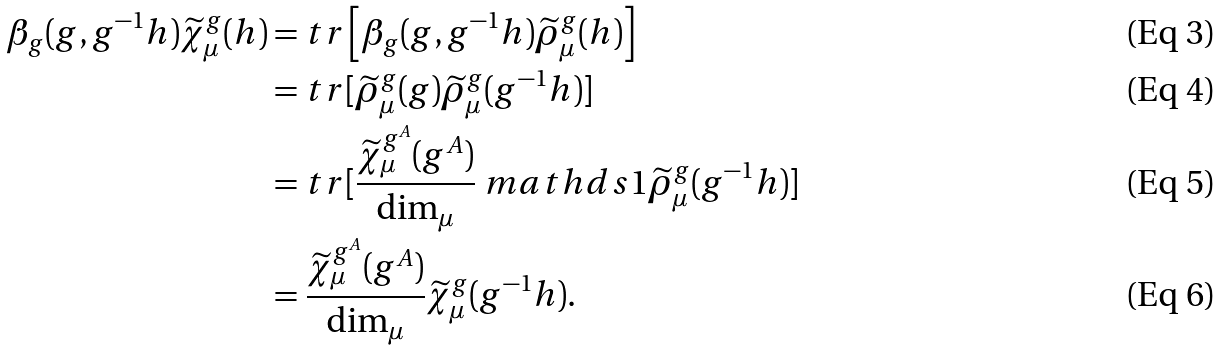<formula> <loc_0><loc_0><loc_500><loc_500>\beta _ { g } ( g , g ^ { - 1 } h ) \widetilde { \chi } ^ { g } _ { \mu } ( h ) & = t r \left [ \beta _ { g } ( g , g ^ { - 1 } h ) \widetilde { \rho } ^ { g } _ { \mu } ( h ) \right ] \\ & = t r [ \widetilde { \rho } ^ { g } _ { \mu } ( g ) \widetilde { \rho } ^ { g } _ { \mu } ( g ^ { - 1 } h ) ] \\ & = t r [ \frac { \widetilde { \chi } ^ { g ^ { A } } _ { \mu } ( g ^ { A } ) } { \text {dim} _ { \mu } } \ m a t h d s { 1 } \widetilde { \rho } ^ { g } _ { \mu } ( g ^ { - 1 } h ) ] \\ & = \frac { \widetilde { \chi } ^ { g ^ { A } } _ { \mu } ( g ^ { A } ) } { \text {dim} _ { \mu } } \widetilde { \chi } ^ { g } _ { \mu } ( g ^ { - 1 } h ) .</formula> 